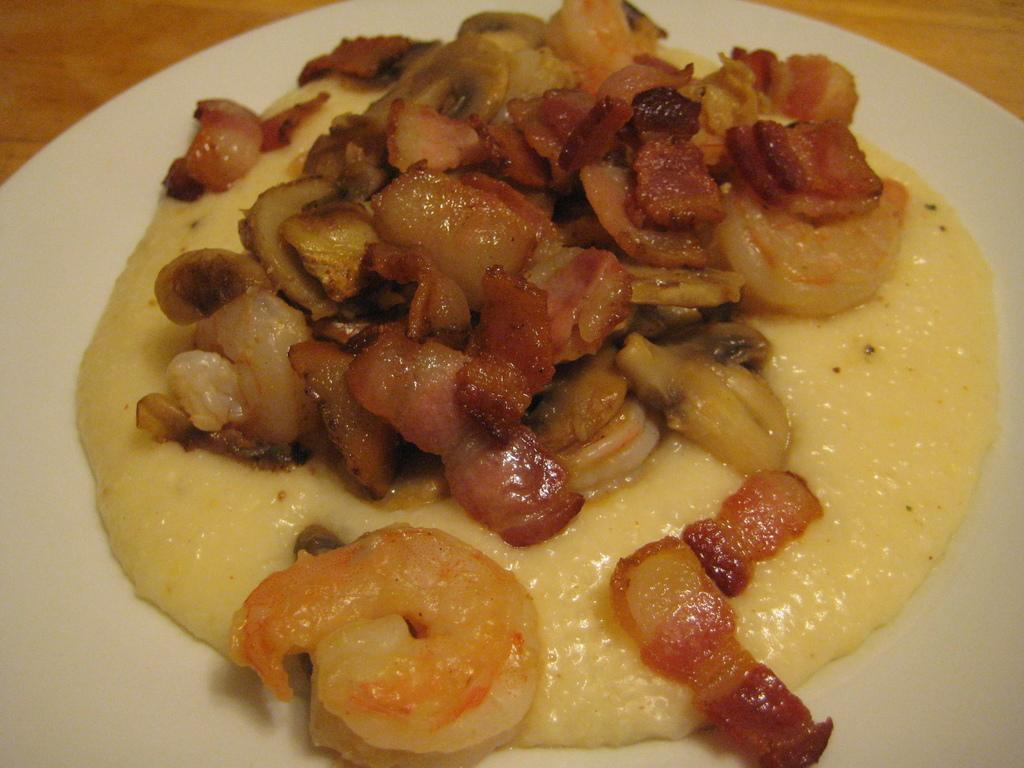What is on the white plate in the image? There are food items on a white plate in the image. What is the white plate placed on? The white plate is on a wooden object. Can you find the receipt for the food items on the white plate in the image? There is no receipt present in the image; it only shows food items on a white plate and the wooden object it is placed on. 